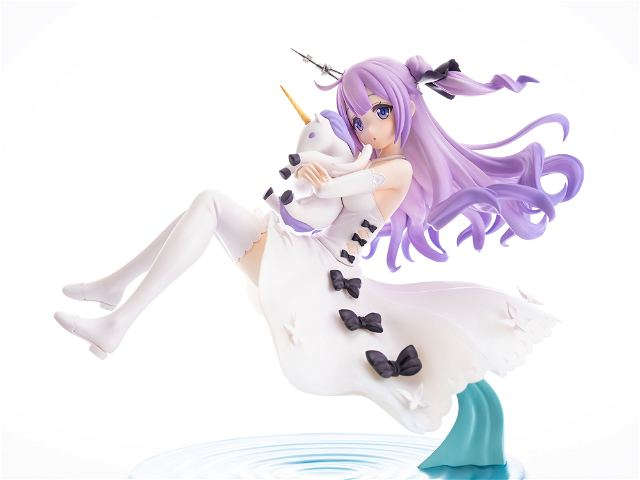Considering the dynamic pose and the design elements of the figure, what might be the implied narrative or theme behind this character's design, and how do the specific details of the figure contribute to that narrative or theme? The implied narrative or theme behind this character's design seems to be one of fantasy and whimsy, as indicated by the presence of the unicorn plush toy, a creature often associated with magical stories. The flowing hair and dress, along with the splash-like stand, contribute to a sense of motion and lightness, as if the character is in the midst of a magical leap or flight. The white and purple color scheme, along with the black bow accents, add a touch of elegance and contrast, which might suggest a character that is both graceful and playful. Overall, the figure seems to encapsulate a moment of joyful freedom within a fantastical context. 